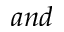<formula> <loc_0><loc_0><loc_500><loc_500>a n d</formula> 